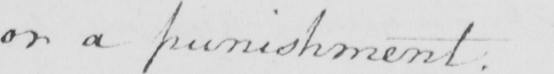Transcribe the text shown in this historical manuscript line. or a punishment . 